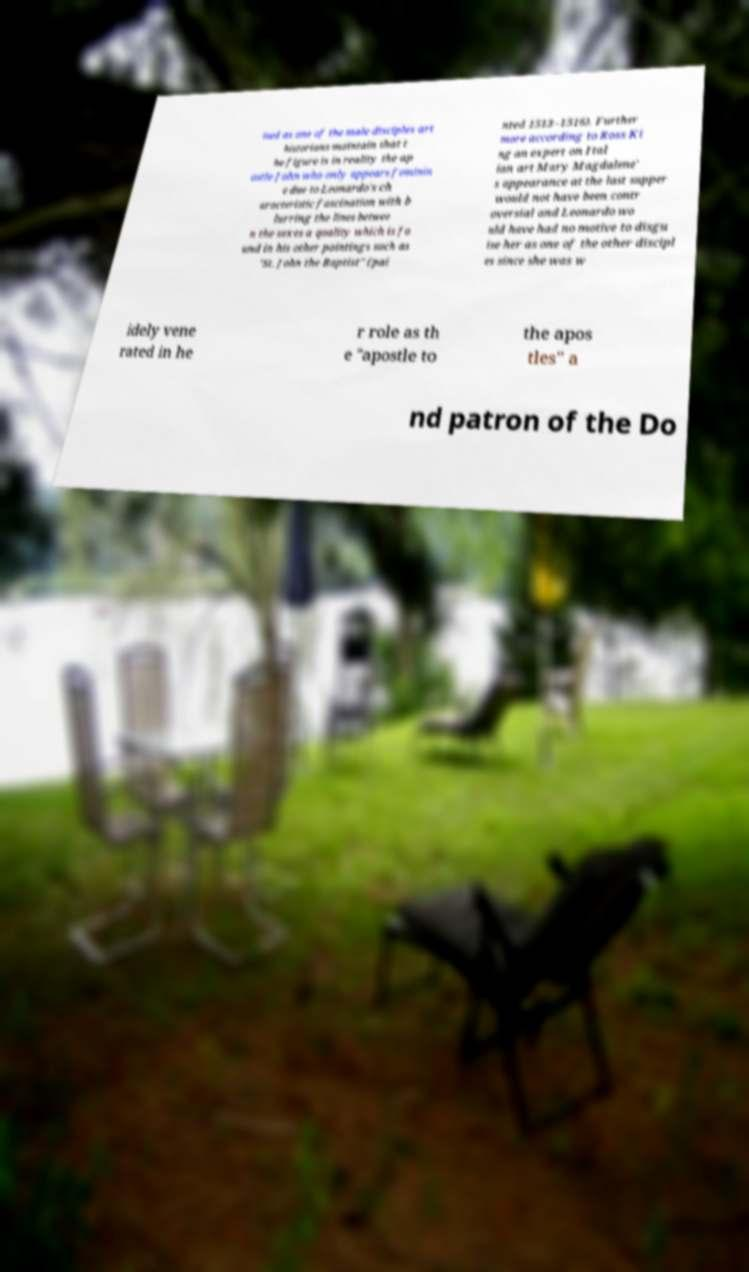There's text embedded in this image that I need extracted. Can you transcribe it verbatim? ised as one of the male disciples art historians maintain that t he figure is in reality the ap ostle John who only appears feminin e due to Leonardo's ch aracteristic fascination with b lurring the lines betwee n the sexes a quality which is fo und in his other paintings such as "St. John the Baptist" (pai nted 1513–1516). Further more according to Ross Ki ng an expert on Ital ian art Mary Magdalene' s appearance at the last supper would not have been contr oversial and Leonardo wo uld have had no motive to disgu ise her as one of the other discipl es since she was w idely vene rated in he r role as th e "apostle to the apos tles" a nd patron of the Do 